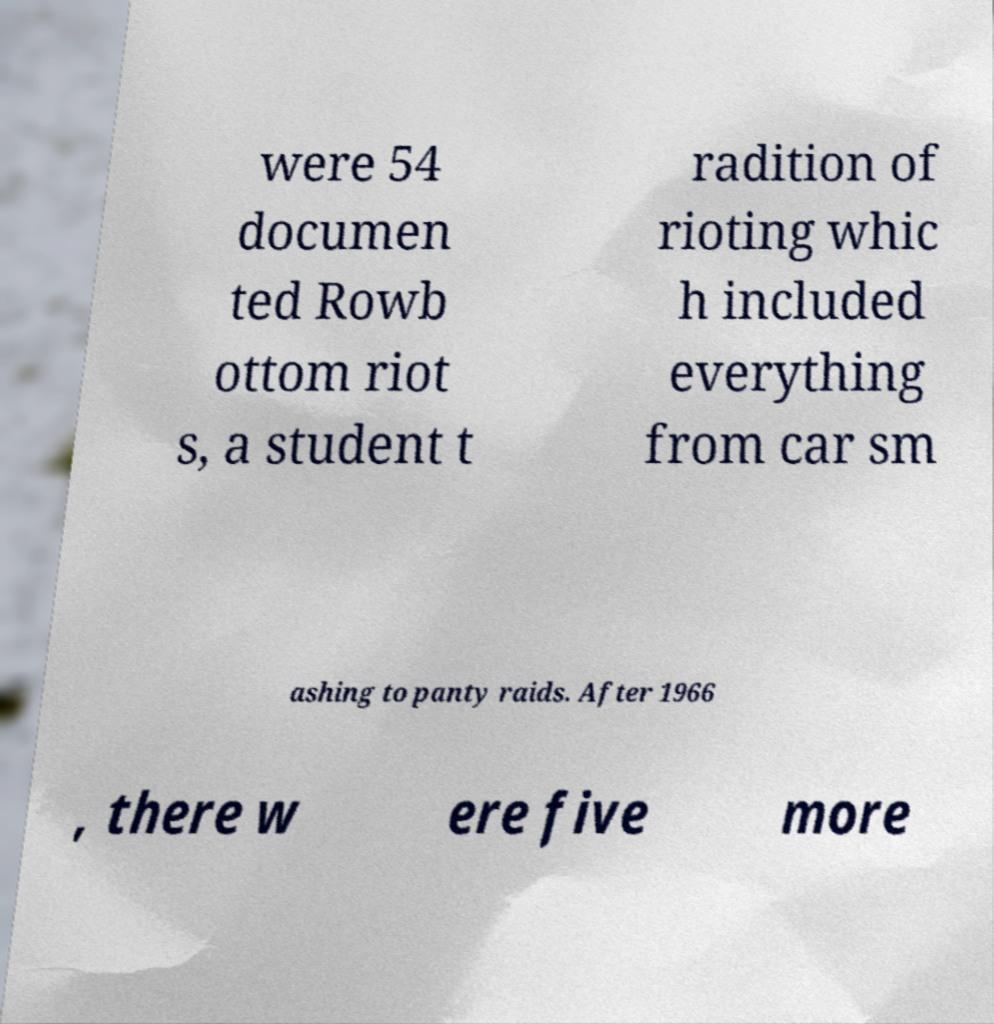Could you assist in decoding the text presented in this image and type it out clearly? were 54 documen ted Rowb ottom riot s, a student t radition of rioting whic h included everything from car sm ashing to panty raids. After 1966 , there w ere five more 